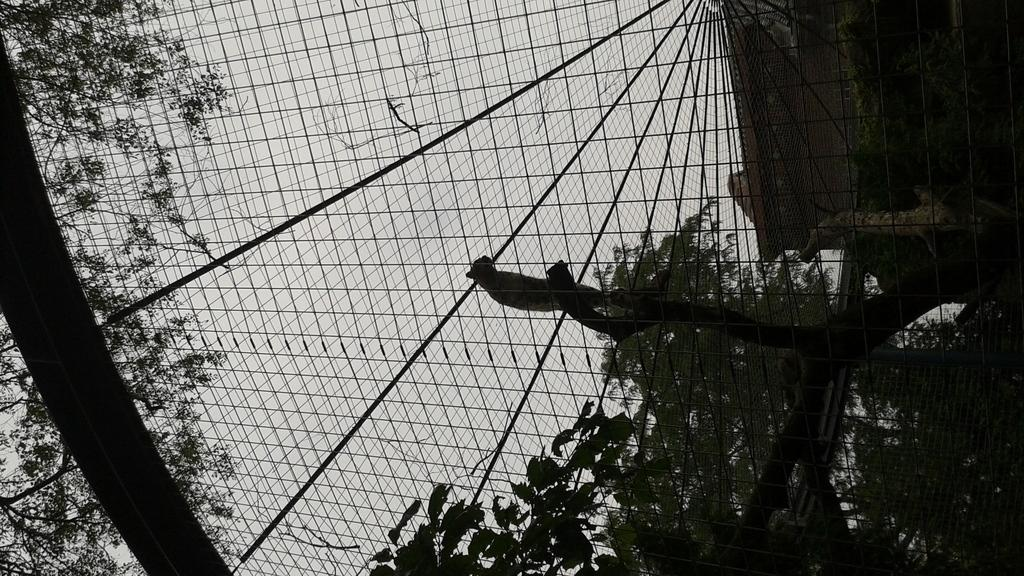What type of creature can be seen in the image? There is an animal in the image. Where is the animal located? The animal is in a cage. What type of vegetation is visible in the image? There are green color trees in the image. What part of the natural environment is visible in the image? The sky is visible in the image. How many people are standing in the shade provided by the trees in the image? There are no people present in the image, and therefore no one is standing in the shade provided by the trees. 